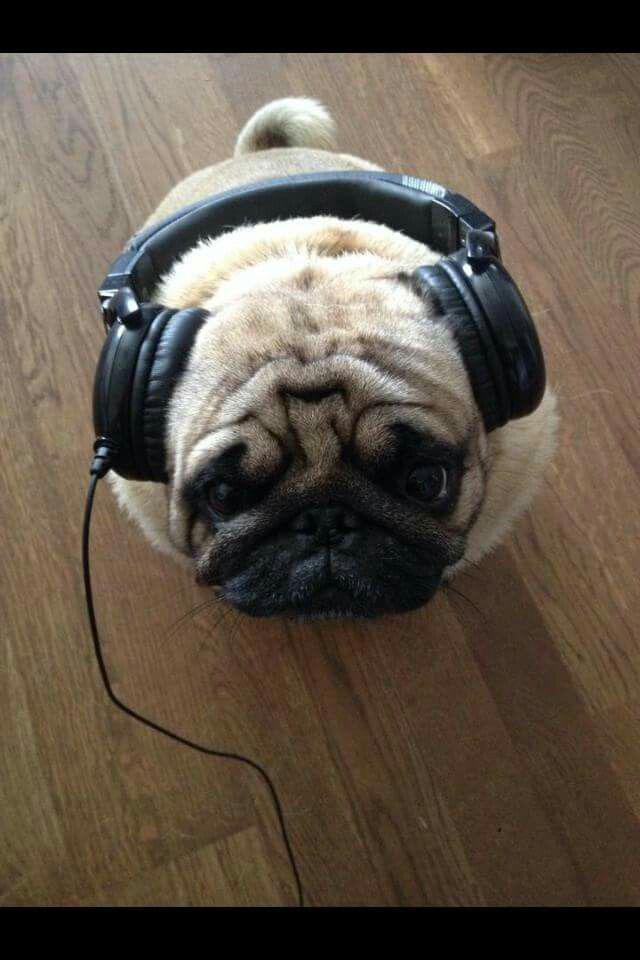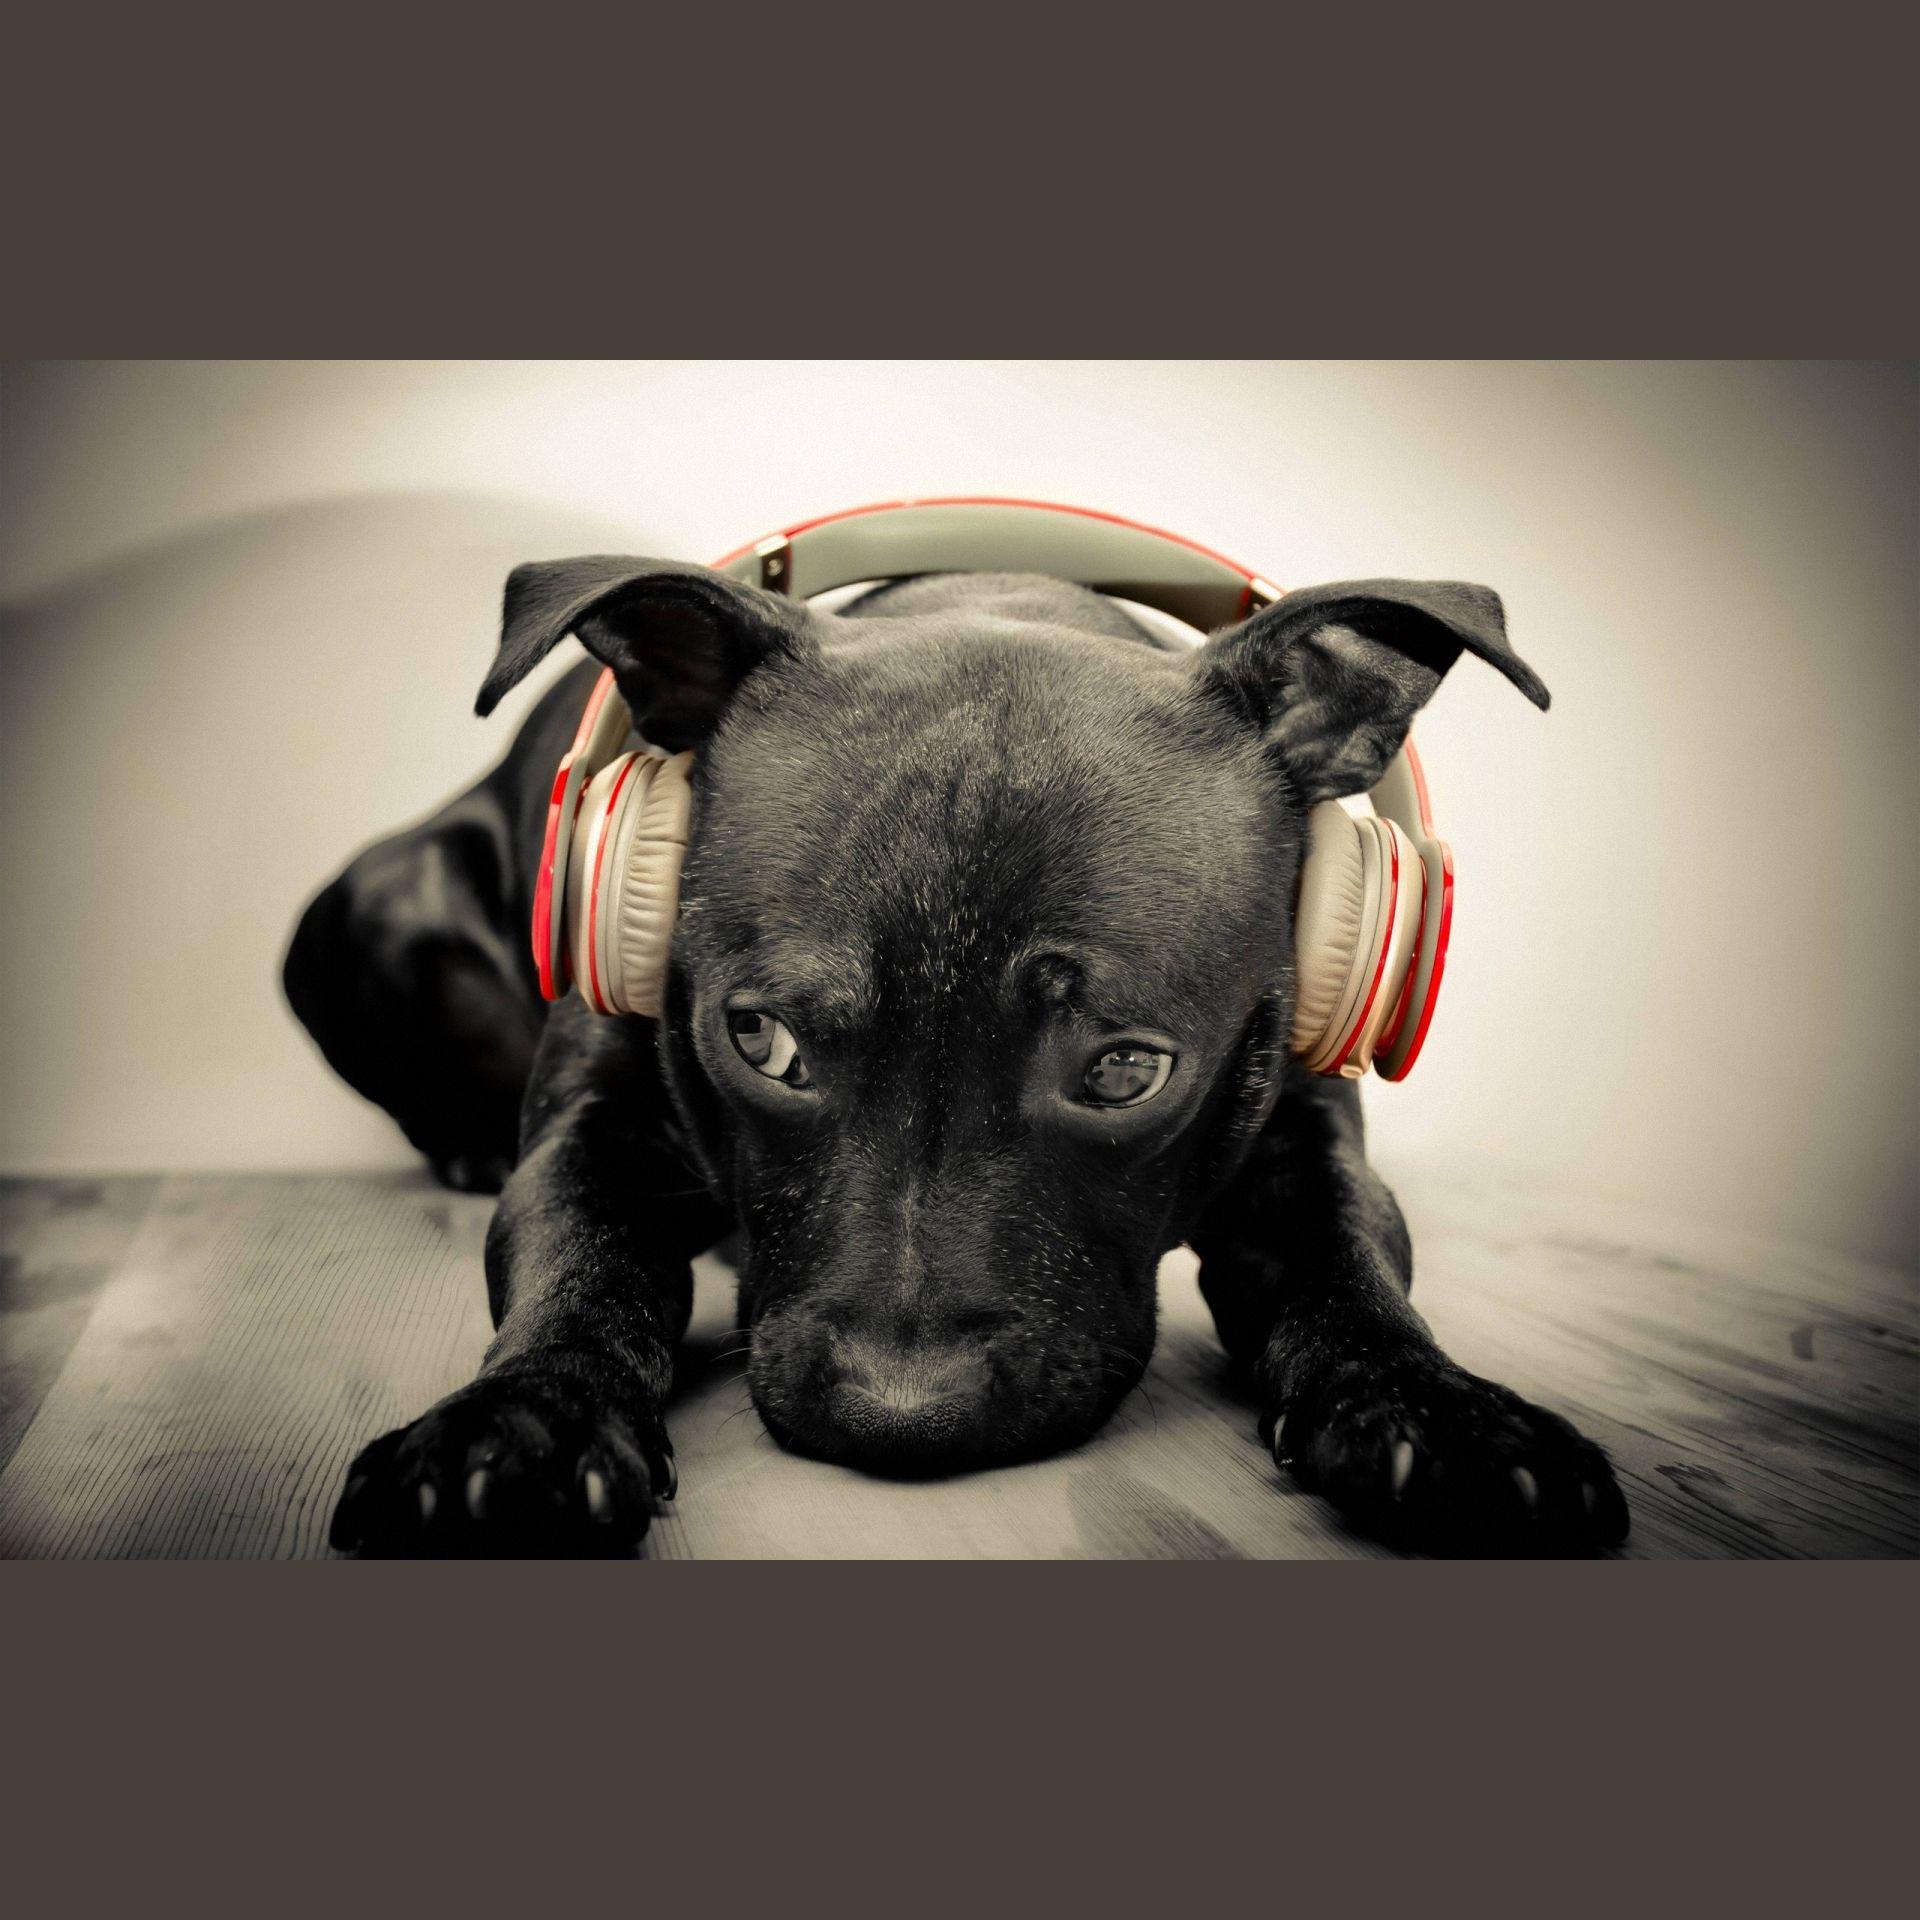The first image is the image on the left, the second image is the image on the right. For the images shown, is this caption "An image shows a pug dog wearing some type of band over its head." true? Answer yes or no. Yes. The first image is the image on the left, the second image is the image on the right. Assess this claim about the two images: "Thre are two dogs in total.". Correct or not? Answer yes or no. Yes. 